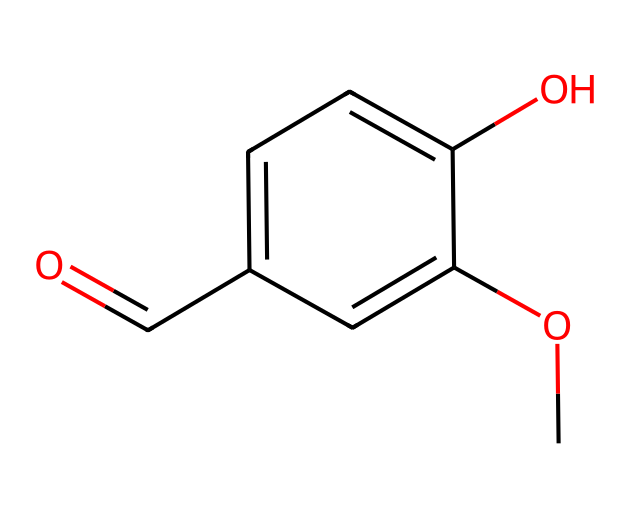How many carbon atoms are present in vanillin? By analyzing the SMILES, we can count the 'C's in the representation. The structure contains six carbon atoms, including those in the aromatic ring and in the aldehyde group.
Answer: six What functional groups are present in vanillin? From the SMILES, we can identify that vanillin contains an aldehyde group (-C=O) and a methoxy group (-OCH3). These two functional groups contribute to its chemical properties and flavor profile.
Answer: aldehyde and methoxy What type of bonding is present in the carbonyl group of vanillin? The carbonyl group, which is part of the aldehyde, features a double bond between carbon and oxygen (C=O), indicating that it has a strong interaction. This type of bond is characteristic of carbonyl functional groups.
Answer: double bond Is vanillin an aromatic compound? The presence of a benzene ring in the structure, indicated by the 'c' in the SMILES, confirms that vanillin is an aromatic compound, which is a key trait of its overall structure and stability.
Answer: Yes How many hydrogen atoms are in vanillin? By analyzing the complete structure derived from the SMILES, we can sum up six hydrogen atoms. The methoxy group contributes three, and the aromatic system plus the aldehyde provides the remaining necessary hydrogen atoms.
Answer: six What is the molecular formula of vanillin? By counting the specific atoms represented in the SMILES structure and combining them accordingly, we find that vanillin has a molecular formula of C8H8O3. This formula reflects the total count of carbon, hydrogen, and oxygen atoms represented.
Answer: C8H8O3 